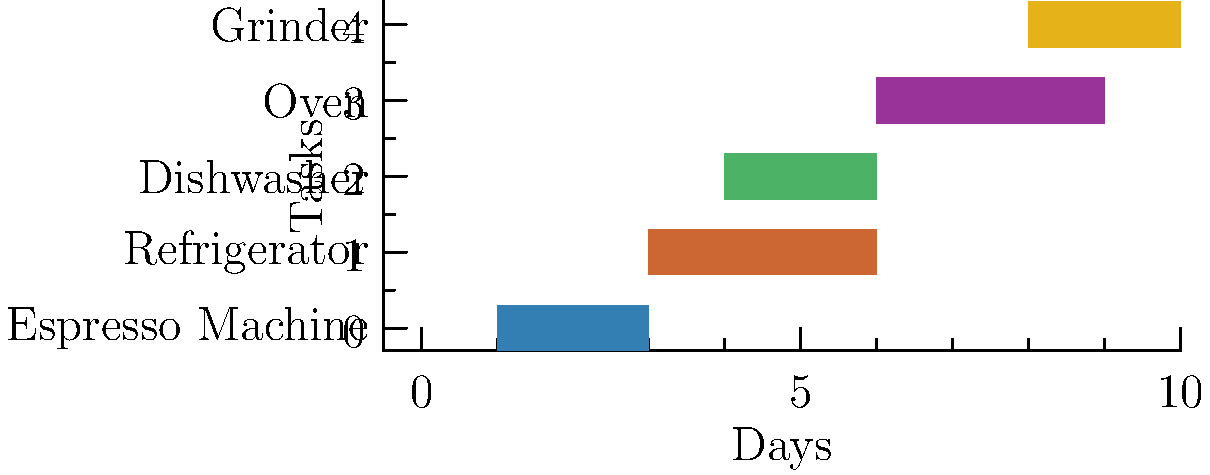Based on the Gantt chart showing the maintenance schedule for various appliances in your cafe, what is the total number of days required to complete all the scheduled repairs, assuming they are performed sequentially? To determine the total number of days required to complete all scheduled repairs sequentially, we need to:

1. Identify the start and duration of each task:
   - Espresso Machine: Starts on day 1, lasts 2 days
   - Refrigerator: Starts on day 3, lasts 3 days
   - Dishwasher: Starts on day 4, lasts 2 days
   - Oven: Starts on day 6, lasts 3 days
   - Grinder: Starts on day 8, lasts 2 days

2. Rearrange the tasks to be performed sequentially:
   - Espresso Machine: Days 1-2 (2 days)
   - Refrigerator: Days 3-5 (3 days)
   - Dishwasher: Days 6-7 (2 days)
   - Oven: Days 8-10 (3 days)
   - Grinder: Days 11-12 (2 days)

3. Sum up the durations:
   $2 + 3 + 2 + 3 + 2 = 12$ days

Therefore, if all repairs were to be performed sequentially, it would take a total of 12 days to complete all scheduled maintenance tasks.
Answer: 12 days 